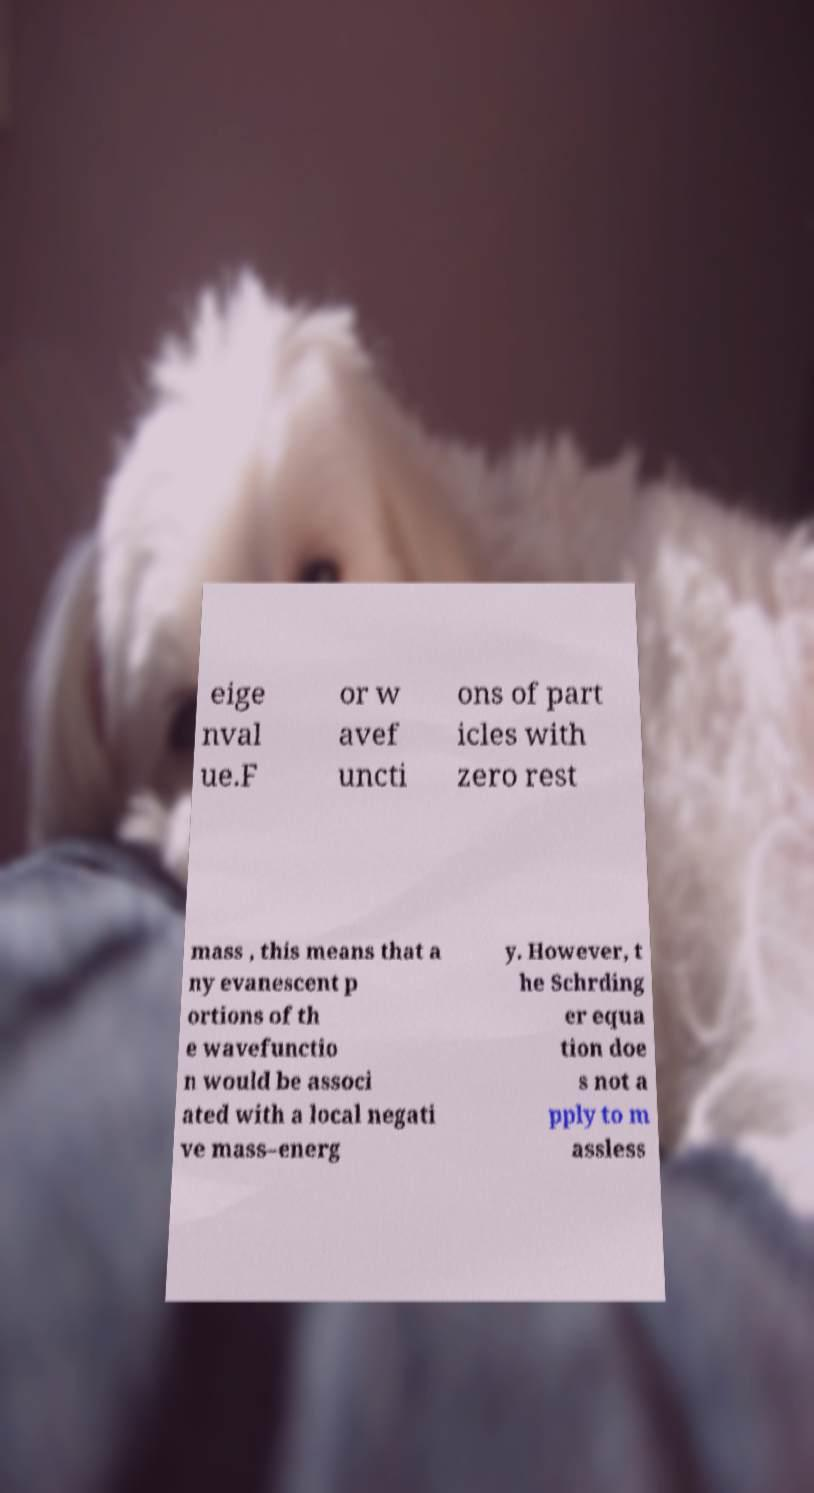Can you read and provide the text displayed in the image?This photo seems to have some interesting text. Can you extract and type it out for me? eige nval ue.F or w avef uncti ons of part icles with zero rest mass , this means that a ny evanescent p ortions of th e wavefunctio n would be associ ated with a local negati ve mass–energ y. However, t he Schrding er equa tion doe s not a pply to m assless 